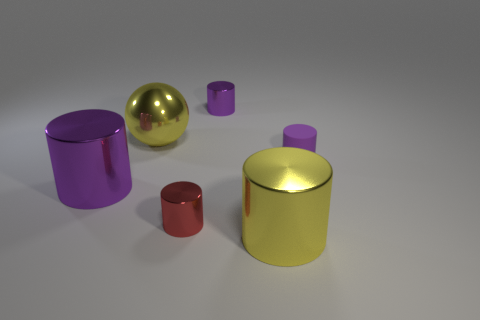What is the size of the yellow shiny thing that is on the left side of the tiny purple shiny cylinder?
Make the answer very short. Large. What shape is the thing that is the same color as the shiny ball?
Make the answer very short. Cylinder. What is the shape of the yellow metallic object that is behind the yellow cylinder that is in front of the small cylinder in front of the large purple cylinder?
Your answer should be very brief. Sphere. How many other objects are the same shape as the big purple shiny object?
Keep it short and to the point. 4. How many rubber objects are big purple objects or big yellow objects?
Give a very brief answer. 0. What material is the tiny purple thing in front of the big yellow shiny thing that is to the left of the yellow cylinder made of?
Provide a succinct answer. Rubber. Is the number of yellow shiny things that are on the left side of the red metallic cylinder greater than the number of big cyan metallic cylinders?
Keep it short and to the point. Yes. Is there a large yellow cylinder that has the same material as the tiny red cylinder?
Give a very brief answer. Yes. Is the shape of the object that is in front of the red metal thing the same as  the large purple thing?
Your answer should be compact. Yes. There is a purple cylinder to the right of the big metallic cylinder right of the tiny purple metallic cylinder; how many small cylinders are behind it?
Offer a terse response. 1. 